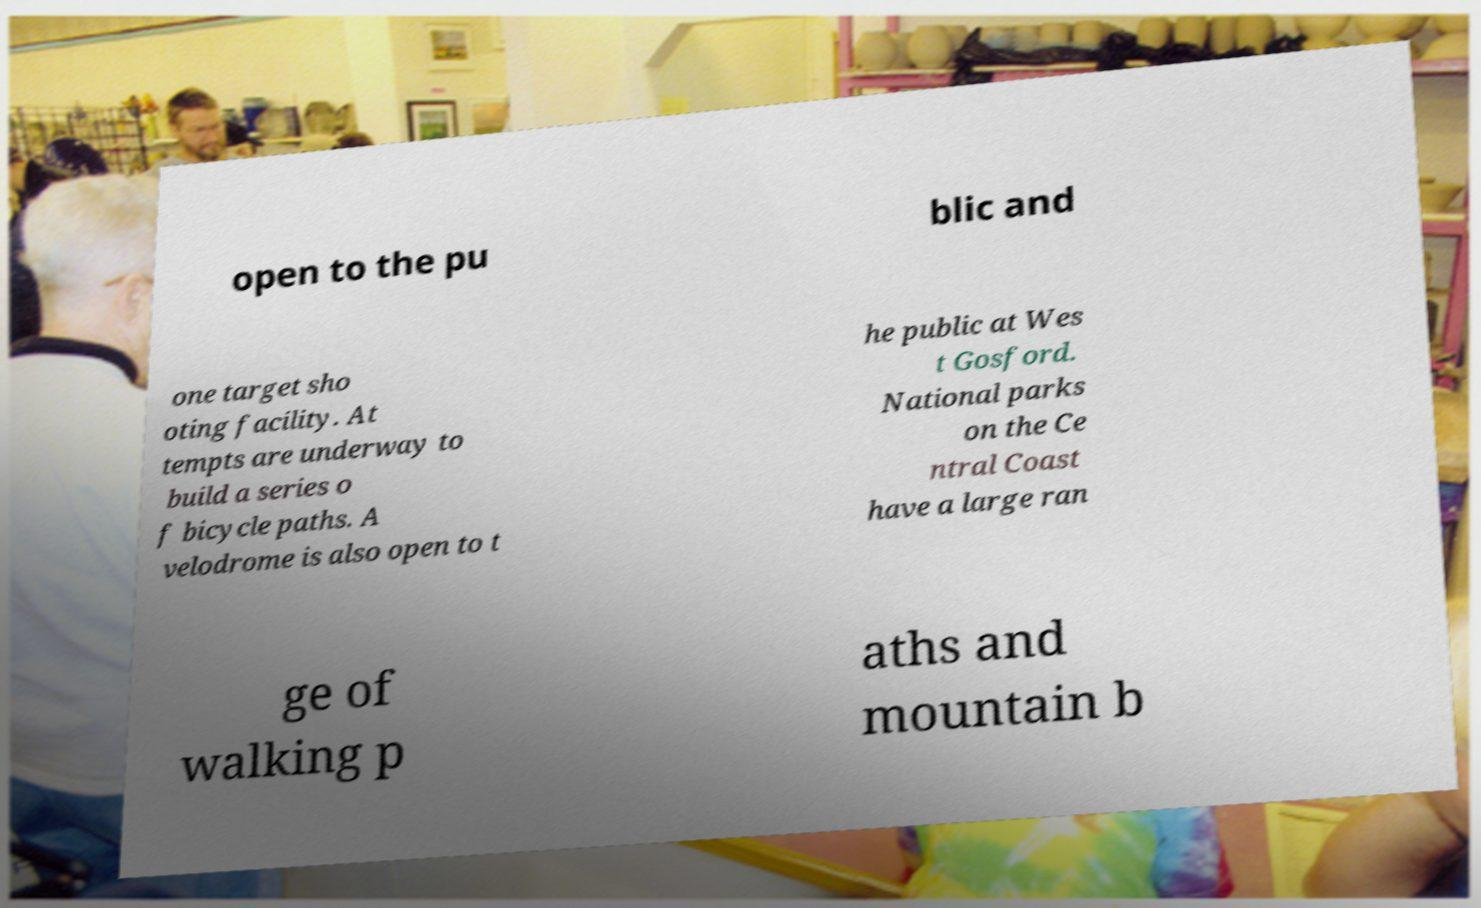Please identify and transcribe the text found in this image. open to the pu blic and one target sho oting facility. At tempts are underway to build a series o f bicycle paths. A velodrome is also open to t he public at Wes t Gosford. National parks on the Ce ntral Coast have a large ran ge of walking p aths and mountain b 